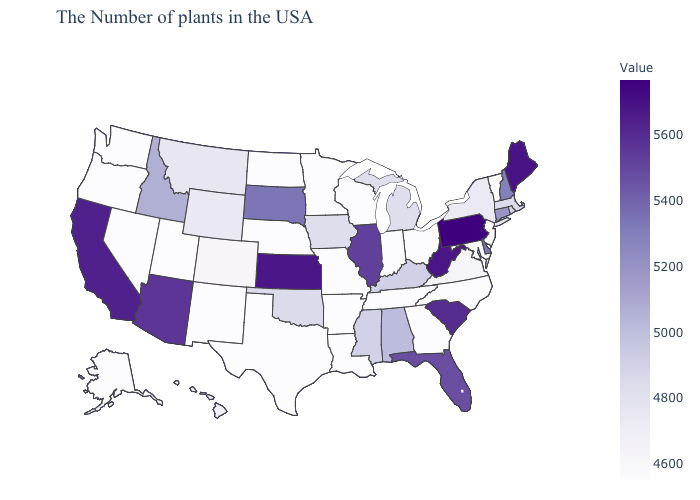Does Pennsylvania have the highest value in the USA?
Write a very short answer. Yes. Among the states that border New Mexico , does Oklahoma have the lowest value?
Keep it brief. No. Does New York have a higher value than Utah?
Quick response, please. Yes. Does Pennsylvania have the highest value in the USA?
Concise answer only. Yes. Which states hav the highest value in the South?
Short answer required. West Virginia. Does New York have the highest value in the Northeast?
Short answer required. No. Does Hawaii have the lowest value in the USA?
Write a very short answer. No. 